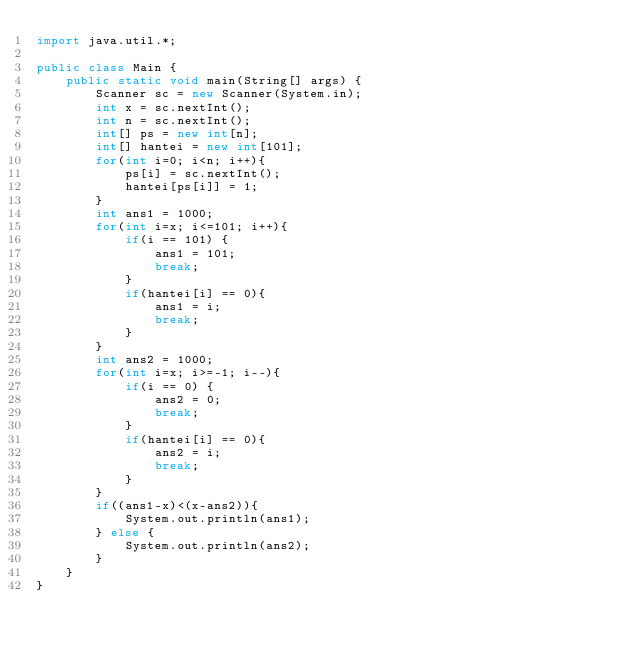<code> <loc_0><loc_0><loc_500><loc_500><_Java_>import java.util.*;

public class Main {
	public static void main(String[] args) {
		Scanner sc = new Scanner(System.in);
		int x = sc.nextInt();
		int n = sc.nextInt();
		int[] ps = new int[n];
		int[] hantei = new int[101];
		for(int i=0; i<n; i++){
			ps[i] = sc.nextInt();
			hantei[ps[i]] = 1;
		}
		int ans1 = 1000;
		for(int i=x; i<=101; i++){
			if(i == 101) {
				ans1 = 101;
				break;
			}
			if(hantei[i] == 0){
				ans1 = i;
				break;
			}
		}
		int ans2 = 1000;
		for(int i=x; i>=-1; i--){
			if(i == 0) {
				ans2 = 0;
				break;
			}
			if(hantei[i] == 0){
				ans2 = i;
				break;
			}
		}
		if((ans1-x)<(x-ans2)){
			System.out.println(ans1);
		} else {
			System.out.println(ans2);
		}
	}
}
</code> 